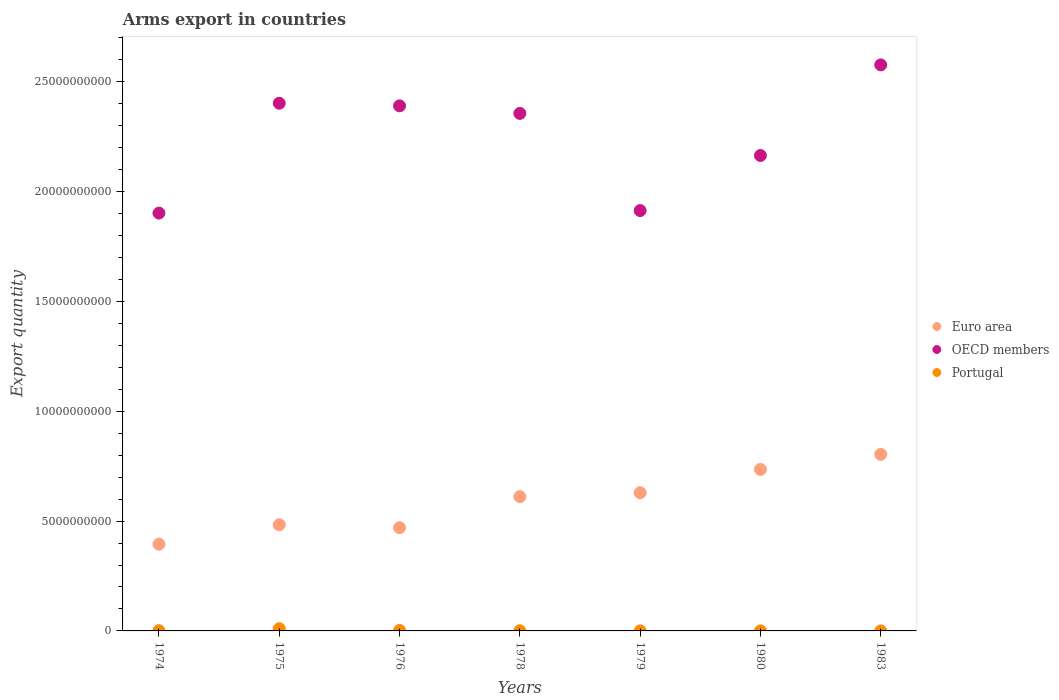How many different coloured dotlines are there?
Your answer should be very brief. 3. Is the number of dotlines equal to the number of legend labels?
Provide a short and direct response. Yes. What is the total arms export in Portugal in 1975?
Make the answer very short. 1.01e+08. Across all years, what is the maximum total arms export in OECD members?
Offer a very short reply. 2.58e+1. Across all years, what is the minimum total arms export in OECD members?
Provide a succinct answer. 1.90e+1. In which year was the total arms export in Euro area maximum?
Give a very brief answer. 1983. In which year was the total arms export in OECD members minimum?
Keep it short and to the point. 1974. What is the total total arms export in Euro area in the graph?
Make the answer very short. 4.13e+1. What is the difference between the total arms export in OECD members in 1975 and that in 1980?
Provide a short and direct response. 2.38e+09. What is the difference between the total arms export in Euro area in 1976 and the total arms export in Portugal in 1974?
Your answer should be compact. 4.69e+09. What is the average total arms export in OECD members per year?
Ensure brevity in your answer.  2.24e+1. In the year 1983, what is the difference between the total arms export in Portugal and total arms export in OECD members?
Keep it short and to the point. -2.58e+1. In how many years, is the total arms export in Euro area greater than 25000000000?
Give a very brief answer. 0. What is the ratio of the total arms export in OECD members in 1974 to that in 1980?
Your answer should be very brief. 0.88. Is the difference between the total arms export in Portugal in 1975 and 1980 greater than the difference between the total arms export in OECD members in 1975 and 1980?
Keep it short and to the point. No. What is the difference between the highest and the second highest total arms export in Euro area?
Provide a succinct answer. 6.84e+08. Is it the case that in every year, the sum of the total arms export in Euro area and total arms export in OECD members  is greater than the total arms export in Portugal?
Offer a very short reply. Yes. Is the total arms export in Portugal strictly greater than the total arms export in OECD members over the years?
Make the answer very short. No. How many years are there in the graph?
Ensure brevity in your answer.  7. Does the graph contain any zero values?
Your response must be concise. No. What is the title of the graph?
Provide a succinct answer. Arms export in countries. What is the label or title of the X-axis?
Your answer should be very brief. Years. What is the label or title of the Y-axis?
Your response must be concise. Export quantity. What is the Export quantity in Euro area in 1974?
Ensure brevity in your answer.  3.95e+09. What is the Export quantity of OECD members in 1974?
Ensure brevity in your answer.  1.90e+1. What is the Export quantity of Portugal in 1974?
Offer a terse response. 1.10e+07. What is the Export quantity of Euro area in 1975?
Provide a succinct answer. 4.84e+09. What is the Export quantity in OECD members in 1975?
Offer a terse response. 2.40e+1. What is the Export quantity of Portugal in 1975?
Your answer should be very brief. 1.01e+08. What is the Export quantity of Euro area in 1976?
Your response must be concise. 4.70e+09. What is the Export quantity in OECD members in 1976?
Ensure brevity in your answer.  2.39e+1. What is the Export quantity in Portugal in 1976?
Provide a short and direct response. 2.10e+07. What is the Export quantity of Euro area in 1978?
Your response must be concise. 6.11e+09. What is the Export quantity in OECD members in 1978?
Your answer should be compact. 2.36e+1. What is the Export quantity of Portugal in 1978?
Provide a succinct answer. 7.00e+06. What is the Export quantity of Euro area in 1979?
Offer a very short reply. 6.29e+09. What is the Export quantity of OECD members in 1979?
Give a very brief answer. 1.91e+1. What is the Export quantity in Euro area in 1980?
Offer a very short reply. 7.36e+09. What is the Export quantity in OECD members in 1980?
Give a very brief answer. 2.16e+1. What is the Export quantity of Portugal in 1980?
Offer a terse response. 1.00e+06. What is the Export quantity of Euro area in 1983?
Provide a short and direct response. 8.04e+09. What is the Export quantity of OECD members in 1983?
Your answer should be compact. 2.58e+1. Across all years, what is the maximum Export quantity in Euro area?
Your answer should be compact. 8.04e+09. Across all years, what is the maximum Export quantity of OECD members?
Offer a terse response. 2.58e+1. Across all years, what is the maximum Export quantity in Portugal?
Ensure brevity in your answer.  1.01e+08. Across all years, what is the minimum Export quantity in Euro area?
Your answer should be compact. 3.95e+09. Across all years, what is the minimum Export quantity of OECD members?
Ensure brevity in your answer.  1.90e+1. Across all years, what is the minimum Export quantity of Portugal?
Make the answer very short. 1.00e+06. What is the total Export quantity of Euro area in the graph?
Offer a terse response. 4.13e+1. What is the total Export quantity in OECD members in the graph?
Your answer should be compact. 1.57e+11. What is the total Export quantity in Portugal in the graph?
Your response must be concise. 1.44e+08. What is the difference between the Export quantity of Euro area in 1974 and that in 1975?
Your answer should be compact. -8.85e+08. What is the difference between the Export quantity in OECD members in 1974 and that in 1975?
Your response must be concise. -5.00e+09. What is the difference between the Export quantity of Portugal in 1974 and that in 1975?
Keep it short and to the point. -9.00e+07. What is the difference between the Export quantity in Euro area in 1974 and that in 1976?
Keep it short and to the point. -7.50e+08. What is the difference between the Export quantity in OECD members in 1974 and that in 1976?
Provide a succinct answer. -4.88e+09. What is the difference between the Export quantity in Portugal in 1974 and that in 1976?
Your response must be concise. -1.00e+07. What is the difference between the Export quantity in Euro area in 1974 and that in 1978?
Provide a short and direct response. -2.16e+09. What is the difference between the Export quantity of OECD members in 1974 and that in 1978?
Provide a short and direct response. -4.54e+09. What is the difference between the Export quantity of Euro area in 1974 and that in 1979?
Ensure brevity in your answer.  -2.34e+09. What is the difference between the Export quantity in OECD members in 1974 and that in 1979?
Give a very brief answer. -1.15e+08. What is the difference between the Export quantity of Portugal in 1974 and that in 1979?
Your answer should be compact. 9.00e+06. What is the difference between the Export quantity in Euro area in 1974 and that in 1980?
Offer a very short reply. -3.40e+09. What is the difference between the Export quantity in OECD members in 1974 and that in 1980?
Your answer should be very brief. -2.62e+09. What is the difference between the Export quantity in Portugal in 1974 and that in 1980?
Your answer should be very brief. 1.00e+07. What is the difference between the Export quantity of Euro area in 1974 and that in 1983?
Give a very brief answer. -4.09e+09. What is the difference between the Export quantity of OECD members in 1974 and that in 1983?
Ensure brevity in your answer.  -6.75e+09. What is the difference between the Export quantity in Euro area in 1975 and that in 1976?
Make the answer very short. 1.35e+08. What is the difference between the Export quantity in OECD members in 1975 and that in 1976?
Provide a succinct answer. 1.18e+08. What is the difference between the Export quantity of Portugal in 1975 and that in 1976?
Offer a very short reply. 8.00e+07. What is the difference between the Export quantity of Euro area in 1975 and that in 1978?
Give a very brief answer. -1.28e+09. What is the difference between the Export quantity of OECD members in 1975 and that in 1978?
Your response must be concise. 4.63e+08. What is the difference between the Export quantity in Portugal in 1975 and that in 1978?
Offer a very short reply. 9.40e+07. What is the difference between the Export quantity of Euro area in 1975 and that in 1979?
Ensure brevity in your answer.  -1.46e+09. What is the difference between the Export quantity of OECD members in 1975 and that in 1979?
Ensure brevity in your answer.  4.89e+09. What is the difference between the Export quantity of Portugal in 1975 and that in 1979?
Your answer should be very brief. 9.90e+07. What is the difference between the Export quantity of Euro area in 1975 and that in 1980?
Offer a terse response. -2.52e+09. What is the difference between the Export quantity in OECD members in 1975 and that in 1980?
Offer a very short reply. 2.38e+09. What is the difference between the Export quantity of Euro area in 1975 and that in 1983?
Provide a succinct answer. -3.20e+09. What is the difference between the Export quantity of OECD members in 1975 and that in 1983?
Your answer should be compact. -1.75e+09. What is the difference between the Export quantity of Portugal in 1975 and that in 1983?
Provide a short and direct response. 1.00e+08. What is the difference between the Export quantity in Euro area in 1976 and that in 1978?
Offer a terse response. -1.41e+09. What is the difference between the Export quantity of OECD members in 1976 and that in 1978?
Keep it short and to the point. 3.45e+08. What is the difference between the Export quantity in Portugal in 1976 and that in 1978?
Give a very brief answer. 1.40e+07. What is the difference between the Export quantity of Euro area in 1976 and that in 1979?
Your answer should be compact. -1.59e+09. What is the difference between the Export quantity of OECD members in 1976 and that in 1979?
Provide a succinct answer. 4.77e+09. What is the difference between the Export quantity in Portugal in 1976 and that in 1979?
Make the answer very short. 1.90e+07. What is the difference between the Export quantity in Euro area in 1976 and that in 1980?
Offer a terse response. -2.65e+09. What is the difference between the Export quantity of OECD members in 1976 and that in 1980?
Offer a very short reply. 2.26e+09. What is the difference between the Export quantity in Portugal in 1976 and that in 1980?
Your answer should be compact. 2.00e+07. What is the difference between the Export quantity of Euro area in 1976 and that in 1983?
Offer a very short reply. -3.34e+09. What is the difference between the Export quantity in OECD members in 1976 and that in 1983?
Provide a succinct answer. -1.86e+09. What is the difference between the Export quantity in Portugal in 1976 and that in 1983?
Your answer should be compact. 2.00e+07. What is the difference between the Export quantity in Euro area in 1978 and that in 1979?
Your answer should be compact. -1.81e+08. What is the difference between the Export quantity of OECD members in 1978 and that in 1979?
Give a very brief answer. 4.42e+09. What is the difference between the Export quantity of Portugal in 1978 and that in 1979?
Your answer should be compact. 5.00e+06. What is the difference between the Export quantity of Euro area in 1978 and that in 1980?
Keep it short and to the point. -1.24e+09. What is the difference between the Export quantity in OECD members in 1978 and that in 1980?
Your response must be concise. 1.92e+09. What is the difference between the Export quantity of Portugal in 1978 and that in 1980?
Offer a very short reply. 6.00e+06. What is the difference between the Export quantity in Euro area in 1978 and that in 1983?
Provide a short and direct response. -1.93e+09. What is the difference between the Export quantity of OECD members in 1978 and that in 1983?
Your answer should be very brief. -2.21e+09. What is the difference between the Export quantity of Euro area in 1979 and that in 1980?
Offer a very short reply. -1.06e+09. What is the difference between the Export quantity of OECD members in 1979 and that in 1980?
Your response must be concise. -2.51e+09. What is the difference between the Export quantity of Euro area in 1979 and that in 1983?
Ensure brevity in your answer.  -1.74e+09. What is the difference between the Export quantity in OECD members in 1979 and that in 1983?
Offer a terse response. -6.63e+09. What is the difference between the Export quantity of Euro area in 1980 and that in 1983?
Provide a short and direct response. -6.84e+08. What is the difference between the Export quantity of OECD members in 1980 and that in 1983?
Offer a terse response. -4.13e+09. What is the difference between the Export quantity of Euro area in 1974 and the Export quantity of OECD members in 1975?
Keep it short and to the point. -2.01e+1. What is the difference between the Export quantity of Euro area in 1974 and the Export quantity of Portugal in 1975?
Offer a terse response. 3.85e+09. What is the difference between the Export quantity of OECD members in 1974 and the Export quantity of Portugal in 1975?
Ensure brevity in your answer.  1.89e+1. What is the difference between the Export quantity of Euro area in 1974 and the Export quantity of OECD members in 1976?
Offer a very short reply. -2.00e+1. What is the difference between the Export quantity of Euro area in 1974 and the Export quantity of Portugal in 1976?
Ensure brevity in your answer.  3.93e+09. What is the difference between the Export quantity in OECD members in 1974 and the Export quantity in Portugal in 1976?
Keep it short and to the point. 1.90e+1. What is the difference between the Export quantity in Euro area in 1974 and the Export quantity in OECD members in 1978?
Provide a succinct answer. -1.96e+1. What is the difference between the Export quantity in Euro area in 1974 and the Export quantity in Portugal in 1978?
Your response must be concise. 3.94e+09. What is the difference between the Export quantity in OECD members in 1974 and the Export quantity in Portugal in 1978?
Your answer should be compact. 1.90e+1. What is the difference between the Export quantity in Euro area in 1974 and the Export quantity in OECD members in 1979?
Offer a very short reply. -1.52e+1. What is the difference between the Export quantity of Euro area in 1974 and the Export quantity of Portugal in 1979?
Offer a very short reply. 3.95e+09. What is the difference between the Export quantity in OECD members in 1974 and the Export quantity in Portugal in 1979?
Provide a short and direct response. 1.90e+1. What is the difference between the Export quantity in Euro area in 1974 and the Export quantity in OECD members in 1980?
Your answer should be compact. -1.77e+1. What is the difference between the Export quantity in Euro area in 1974 and the Export quantity in Portugal in 1980?
Offer a terse response. 3.95e+09. What is the difference between the Export quantity of OECD members in 1974 and the Export quantity of Portugal in 1980?
Give a very brief answer. 1.90e+1. What is the difference between the Export quantity in Euro area in 1974 and the Export quantity in OECD members in 1983?
Your response must be concise. -2.18e+1. What is the difference between the Export quantity of Euro area in 1974 and the Export quantity of Portugal in 1983?
Provide a succinct answer. 3.95e+09. What is the difference between the Export quantity of OECD members in 1974 and the Export quantity of Portugal in 1983?
Offer a terse response. 1.90e+1. What is the difference between the Export quantity in Euro area in 1975 and the Export quantity in OECD members in 1976?
Keep it short and to the point. -1.91e+1. What is the difference between the Export quantity of Euro area in 1975 and the Export quantity of Portugal in 1976?
Make the answer very short. 4.82e+09. What is the difference between the Export quantity in OECD members in 1975 and the Export quantity in Portugal in 1976?
Offer a very short reply. 2.40e+1. What is the difference between the Export quantity in Euro area in 1975 and the Export quantity in OECD members in 1978?
Ensure brevity in your answer.  -1.87e+1. What is the difference between the Export quantity in Euro area in 1975 and the Export quantity in Portugal in 1978?
Offer a terse response. 4.83e+09. What is the difference between the Export quantity of OECD members in 1975 and the Export quantity of Portugal in 1978?
Your response must be concise. 2.40e+1. What is the difference between the Export quantity in Euro area in 1975 and the Export quantity in OECD members in 1979?
Ensure brevity in your answer.  -1.43e+1. What is the difference between the Export quantity in Euro area in 1975 and the Export quantity in Portugal in 1979?
Your answer should be compact. 4.83e+09. What is the difference between the Export quantity of OECD members in 1975 and the Export quantity of Portugal in 1979?
Provide a short and direct response. 2.40e+1. What is the difference between the Export quantity of Euro area in 1975 and the Export quantity of OECD members in 1980?
Offer a terse response. -1.68e+1. What is the difference between the Export quantity in Euro area in 1975 and the Export quantity in Portugal in 1980?
Offer a very short reply. 4.84e+09. What is the difference between the Export quantity in OECD members in 1975 and the Export quantity in Portugal in 1980?
Make the answer very short. 2.40e+1. What is the difference between the Export quantity in Euro area in 1975 and the Export quantity in OECD members in 1983?
Provide a short and direct response. -2.09e+1. What is the difference between the Export quantity in Euro area in 1975 and the Export quantity in Portugal in 1983?
Make the answer very short. 4.84e+09. What is the difference between the Export quantity in OECD members in 1975 and the Export quantity in Portugal in 1983?
Provide a succinct answer. 2.40e+1. What is the difference between the Export quantity of Euro area in 1976 and the Export quantity of OECD members in 1978?
Ensure brevity in your answer.  -1.89e+1. What is the difference between the Export quantity in Euro area in 1976 and the Export quantity in Portugal in 1978?
Make the answer very short. 4.69e+09. What is the difference between the Export quantity in OECD members in 1976 and the Export quantity in Portugal in 1978?
Offer a terse response. 2.39e+1. What is the difference between the Export quantity in Euro area in 1976 and the Export quantity in OECD members in 1979?
Make the answer very short. -1.44e+1. What is the difference between the Export quantity of Euro area in 1976 and the Export quantity of Portugal in 1979?
Your answer should be compact. 4.70e+09. What is the difference between the Export quantity in OECD members in 1976 and the Export quantity in Portugal in 1979?
Provide a short and direct response. 2.39e+1. What is the difference between the Export quantity of Euro area in 1976 and the Export quantity of OECD members in 1980?
Provide a succinct answer. -1.69e+1. What is the difference between the Export quantity of Euro area in 1976 and the Export quantity of Portugal in 1980?
Offer a very short reply. 4.70e+09. What is the difference between the Export quantity in OECD members in 1976 and the Export quantity in Portugal in 1980?
Keep it short and to the point. 2.39e+1. What is the difference between the Export quantity in Euro area in 1976 and the Export quantity in OECD members in 1983?
Your answer should be compact. -2.11e+1. What is the difference between the Export quantity of Euro area in 1976 and the Export quantity of Portugal in 1983?
Your answer should be very brief. 4.70e+09. What is the difference between the Export quantity of OECD members in 1976 and the Export quantity of Portugal in 1983?
Offer a very short reply. 2.39e+1. What is the difference between the Export quantity in Euro area in 1978 and the Export quantity in OECD members in 1979?
Keep it short and to the point. -1.30e+1. What is the difference between the Export quantity in Euro area in 1978 and the Export quantity in Portugal in 1979?
Your response must be concise. 6.11e+09. What is the difference between the Export quantity of OECD members in 1978 and the Export quantity of Portugal in 1979?
Your response must be concise. 2.36e+1. What is the difference between the Export quantity in Euro area in 1978 and the Export quantity in OECD members in 1980?
Offer a very short reply. -1.55e+1. What is the difference between the Export quantity of Euro area in 1978 and the Export quantity of Portugal in 1980?
Provide a succinct answer. 6.11e+09. What is the difference between the Export quantity of OECD members in 1978 and the Export quantity of Portugal in 1980?
Provide a short and direct response. 2.36e+1. What is the difference between the Export quantity in Euro area in 1978 and the Export quantity in OECD members in 1983?
Offer a very short reply. -1.97e+1. What is the difference between the Export quantity in Euro area in 1978 and the Export quantity in Portugal in 1983?
Your response must be concise. 6.11e+09. What is the difference between the Export quantity of OECD members in 1978 and the Export quantity of Portugal in 1983?
Provide a succinct answer. 2.36e+1. What is the difference between the Export quantity of Euro area in 1979 and the Export quantity of OECD members in 1980?
Your answer should be very brief. -1.54e+1. What is the difference between the Export quantity of Euro area in 1979 and the Export quantity of Portugal in 1980?
Ensure brevity in your answer.  6.29e+09. What is the difference between the Export quantity of OECD members in 1979 and the Export quantity of Portugal in 1980?
Give a very brief answer. 1.91e+1. What is the difference between the Export quantity in Euro area in 1979 and the Export quantity in OECD members in 1983?
Offer a terse response. -1.95e+1. What is the difference between the Export quantity in Euro area in 1979 and the Export quantity in Portugal in 1983?
Ensure brevity in your answer.  6.29e+09. What is the difference between the Export quantity in OECD members in 1979 and the Export quantity in Portugal in 1983?
Offer a terse response. 1.91e+1. What is the difference between the Export quantity of Euro area in 1980 and the Export quantity of OECD members in 1983?
Your response must be concise. -1.84e+1. What is the difference between the Export quantity of Euro area in 1980 and the Export quantity of Portugal in 1983?
Ensure brevity in your answer.  7.35e+09. What is the difference between the Export quantity of OECD members in 1980 and the Export quantity of Portugal in 1983?
Offer a very short reply. 2.16e+1. What is the average Export quantity of Euro area per year?
Keep it short and to the point. 5.90e+09. What is the average Export quantity in OECD members per year?
Your answer should be compact. 2.24e+1. What is the average Export quantity in Portugal per year?
Give a very brief answer. 2.06e+07. In the year 1974, what is the difference between the Export quantity of Euro area and Export quantity of OECD members?
Offer a very short reply. -1.51e+1. In the year 1974, what is the difference between the Export quantity in Euro area and Export quantity in Portugal?
Offer a terse response. 3.94e+09. In the year 1974, what is the difference between the Export quantity in OECD members and Export quantity in Portugal?
Ensure brevity in your answer.  1.90e+1. In the year 1975, what is the difference between the Export quantity of Euro area and Export quantity of OECD members?
Your answer should be very brief. -1.92e+1. In the year 1975, what is the difference between the Export quantity of Euro area and Export quantity of Portugal?
Your answer should be very brief. 4.74e+09. In the year 1975, what is the difference between the Export quantity of OECD members and Export quantity of Portugal?
Ensure brevity in your answer.  2.39e+1. In the year 1976, what is the difference between the Export quantity of Euro area and Export quantity of OECD members?
Make the answer very short. -1.92e+1. In the year 1976, what is the difference between the Export quantity of Euro area and Export quantity of Portugal?
Your answer should be compact. 4.68e+09. In the year 1976, what is the difference between the Export quantity of OECD members and Export quantity of Portugal?
Make the answer very short. 2.39e+1. In the year 1978, what is the difference between the Export quantity of Euro area and Export quantity of OECD members?
Keep it short and to the point. -1.75e+1. In the year 1978, what is the difference between the Export quantity in Euro area and Export quantity in Portugal?
Offer a very short reply. 6.11e+09. In the year 1978, what is the difference between the Export quantity in OECD members and Export quantity in Portugal?
Your answer should be compact. 2.36e+1. In the year 1979, what is the difference between the Export quantity in Euro area and Export quantity in OECD members?
Ensure brevity in your answer.  -1.28e+1. In the year 1979, what is the difference between the Export quantity in Euro area and Export quantity in Portugal?
Ensure brevity in your answer.  6.29e+09. In the year 1979, what is the difference between the Export quantity of OECD members and Export quantity of Portugal?
Offer a terse response. 1.91e+1. In the year 1980, what is the difference between the Export quantity of Euro area and Export quantity of OECD members?
Offer a terse response. -1.43e+1. In the year 1980, what is the difference between the Export quantity of Euro area and Export quantity of Portugal?
Offer a terse response. 7.35e+09. In the year 1980, what is the difference between the Export quantity in OECD members and Export quantity in Portugal?
Offer a very short reply. 2.16e+1. In the year 1983, what is the difference between the Export quantity in Euro area and Export quantity in OECD members?
Provide a short and direct response. -1.77e+1. In the year 1983, what is the difference between the Export quantity in Euro area and Export quantity in Portugal?
Your answer should be compact. 8.04e+09. In the year 1983, what is the difference between the Export quantity in OECD members and Export quantity in Portugal?
Provide a short and direct response. 2.58e+1. What is the ratio of the Export quantity in Euro area in 1974 to that in 1975?
Your answer should be compact. 0.82. What is the ratio of the Export quantity of OECD members in 1974 to that in 1975?
Your answer should be very brief. 0.79. What is the ratio of the Export quantity in Portugal in 1974 to that in 1975?
Ensure brevity in your answer.  0.11. What is the ratio of the Export quantity of Euro area in 1974 to that in 1976?
Your answer should be very brief. 0.84. What is the ratio of the Export quantity in OECD members in 1974 to that in 1976?
Your response must be concise. 0.8. What is the ratio of the Export quantity in Portugal in 1974 to that in 1976?
Your response must be concise. 0.52. What is the ratio of the Export quantity in Euro area in 1974 to that in 1978?
Your answer should be compact. 0.65. What is the ratio of the Export quantity of OECD members in 1974 to that in 1978?
Your answer should be compact. 0.81. What is the ratio of the Export quantity of Portugal in 1974 to that in 1978?
Offer a terse response. 1.57. What is the ratio of the Export quantity in Euro area in 1974 to that in 1979?
Offer a very short reply. 0.63. What is the ratio of the Export quantity in Euro area in 1974 to that in 1980?
Provide a succinct answer. 0.54. What is the ratio of the Export quantity of OECD members in 1974 to that in 1980?
Your answer should be compact. 0.88. What is the ratio of the Export quantity in Euro area in 1974 to that in 1983?
Your answer should be very brief. 0.49. What is the ratio of the Export quantity of OECD members in 1974 to that in 1983?
Your response must be concise. 0.74. What is the ratio of the Export quantity in Euro area in 1975 to that in 1976?
Offer a terse response. 1.03. What is the ratio of the Export quantity of OECD members in 1975 to that in 1976?
Offer a terse response. 1. What is the ratio of the Export quantity in Portugal in 1975 to that in 1976?
Offer a terse response. 4.81. What is the ratio of the Export quantity of Euro area in 1975 to that in 1978?
Keep it short and to the point. 0.79. What is the ratio of the Export quantity in OECD members in 1975 to that in 1978?
Your answer should be very brief. 1.02. What is the ratio of the Export quantity of Portugal in 1975 to that in 1978?
Ensure brevity in your answer.  14.43. What is the ratio of the Export quantity of Euro area in 1975 to that in 1979?
Your response must be concise. 0.77. What is the ratio of the Export quantity of OECD members in 1975 to that in 1979?
Keep it short and to the point. 1.26. What is the ratio of the Export quantity in Portugal in 1975 to that in 1979?
Provide a short and direct response. 50.5. What is the ratio of the Export quantity of Euro area in 1975 to that in 1980?
Offer a very short reply. 0.66. What is the ratio of the Export quantity in OECD members in 1975 to that in 1980?
Your response must be concise. 1.11. What is the ratio of the Export quantity in Portugal in 1975 to that in 1980?
Your response must be concise. 101. What is the ratio of the Export quantity in Euro area in 1975 to that in 1983?
Provide a short and direct response. 0.6. What is the ratio of the Export quantity of OECD members in 1975 to that in 1983?
Provide a short and direct response. 0.93. What is the ratio of the Export quantity of Portugal in 1975 to that in 1983?
Make the answer very short. 101. What is the ratio of the Export quantity of Euro area in 1976 to that in 1978?
Your answer should be compact. 0.77. What is the ratio of the Export quantity in OECD members in 1976 to that in 1978?
Provide a succinct answer. 1.01. What is the ratio of the Export quantity in Portugal in 1976 to that in 1978?
Give a very brief answer. 3. What is the ratio of the Export quantity of Euro area in 1976 to that in 1979?
Provide a succinct answer. 0.75. What is the ratio of the Export quantity in OECD members in 1976 to that in 1979?
Keep it short and to the point. 1.25. What is the ratio of the Export quantity in Euro area in 1976 to that in 1980?
Keep it short and to the point. 0.64. What is the ratio of the Export quantity in OECD members in 1976 to that in 1980?
Your answer should be compact. 1.1. What is the ratio of the Export quantity of Portugal in 1976 to that in 1980?
Your response must be concise. 21. What is the ratio of the Export quantity of Euro area in 1976 to that in 1983?
Offer a terse response. 0.58. What is the ratio of the Export quantity in OECD members in 1976 to that in 1983?
Ensure brevity in your answer.  0.93. What is the ratio of the Export quantity of Portugal in 1976 to that in 1983?
Give a very brief answer. 21. What is the ratio of the Export quantity of Euro area in 1978 to that in 1979?
Your response must be concise. 0.97. What is the ratio of the Export quantity in OECD members in 1978 to that in 1979?
Your response must be concise. 1.23. What is the ratio of the Export quantity of Euro area in 1978 to that in 1980?
Your answer should be very brief. 0.83. What is the ratio of the Export quantity of OECD members in 1978 to that in 1980?
Provide a succinct answer. 1.09. What is the ratio of the Export quantity in Euro area in 1978 to that in 1983?
Your answer should be compact. 0.76. What is the ratio of the Export quantity in OECD members in 1978 to that in 1983?
Offer a very short reply. 0.91. What is the ratio of the Export quantity in Euro area in 1979 to that in 1980?
Provide a short and direct response. 0.86. What is the ratio of the Export quantity of OECD members in 1979 to that in 1980?
Offer a terse response. 0.88. What is the ratio of the Export quantity in Euro area in 1979 to that in 1983?
Your answer should be compact. 0.78. What is the ratio of the Export quantity of OECD members in 1979 to that in 1983?
Your answer should be very brief. 0.74. What is the ratio of the Export quantity of Portugal in 1979 to that in 1983?
Offer a very short reply. 2. What is the ratio of the Export quantity of Euro area in 1980 to that in 1983?
Your answer should be very brief. 0.91. What is the ratio of the Export quantity in OECD members in 1980 to that in 1983?
Provide a succinct answer. 0.84. What is the difference between the highest and the second highest Export quantity in Euro area?
Make the answer very short. 6.84e+08. What is the difference between the highest and the second highest Export quantity in OECD members?
Your answer should be compact. 1.75e+09. What is the difference between the highest and the second highest Export quantity in Portugal?
Offer a very short reply. 8.00e+07. What is the difference between the highest and the lowest Export quantity in Euro area?
Your answer should be compact. 4.09e+09. What is the difference between the highest and the lowest Export quantity in OECD members?
Offer a very short reply. 6.75e+09. 